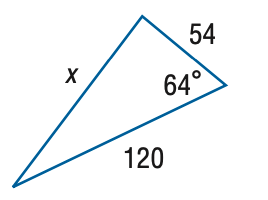Answer the mathemtical geometry problem and directly provide the correct option letter.
Question: Find x. Round the side measure to the nearest tenth.
Choices: A: 53.9 B: 107.9 C: 215.7 D: 323.6 B 